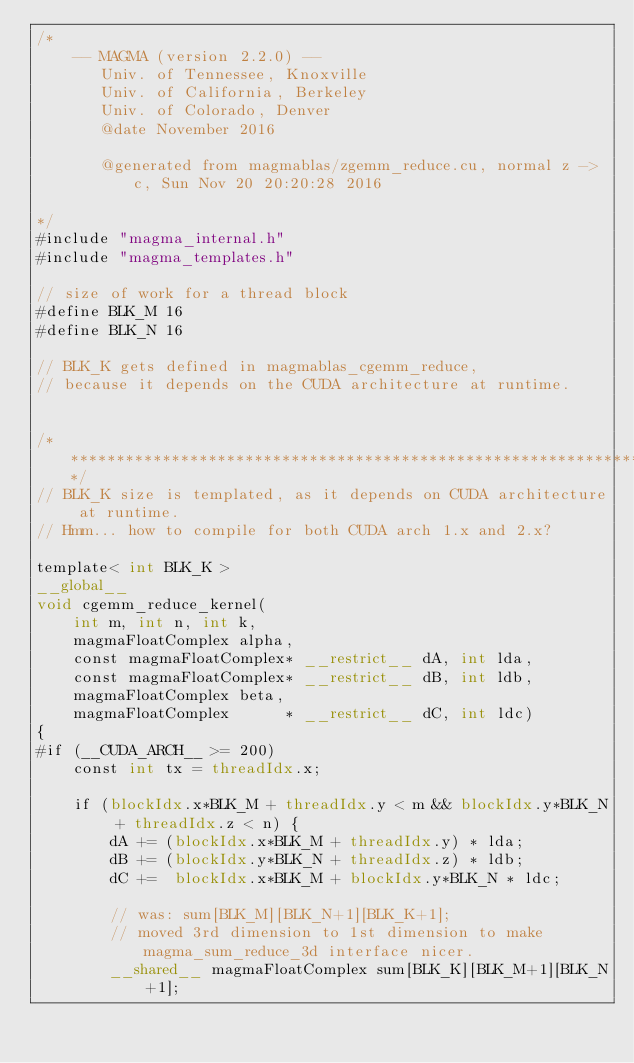<code> <loc_0><loc_0><loc_500><loc_500><_Cuda_>/*
    -- MAGMA (version 2.2.0) --
       Univ. of Tennessee, Knoxville
       Univ. of California, Berkeley
       Univ. of Colorado, Denver
       @date November 2016

       @generated from magmablas/zgemm_reduce.cu, normal z -> c, Sun Nov 20 20:20:28 2016

*/
#include "magma_internal.h"
#include "magma_templates.h"

// size of work for a thread block
#define BLK_M 16
#define BLK_N 16

// BLK_K gets defined in magmablas_cgemm_reduce,
// because it depends on the CUDA architecture at runtime.


/******************************************************************************/
// BLK_K size is templated, as it depends on CUDA architecture at runtime.
// Hmm... how to compile for both CUDA arch 1.x and 2.x?

template< int BLK_K >
__global__
void cgemm_reduce_kernel(
    int m, int n, int k,
    magmaFloatComplex alpha,
    const magmaFloatComplex* __restrict__ dA, int lda,
    const magmaFloatComplex* __restrict__ dB, int ldb,
    magmaFloatComplex beta,
    magmaFloatComplex      * __restrict__ dC, int ldc)
{
#if (__CUDA_ARCH__ >= 200)
    const int tx = threadIdx.x;
    
    if (blockIdx.x*BLK_M + threadIdx.y < m && blockIdx.y*BLK_N + threadIdx.z < n) {
        dA += (blockIdx.x*BLK_M + threadIdx.y) * lda;
        dB += (blockIdx.y*BLK_N + threadIdx.z) * ldb;
        dC +=  blockIdx.x*BLK_M + blockIdx.y*BLK_N * ldc;
        
        // was: sum[BLK_M][BLK_N+1][BLK_K+1];
        // moved 3rd dimension to 1st dimension to make magma_sum_reduce_3d interface nicer.
        __shared__ magmaFloatComplex sum[BLK_K][BLK_M+1][BLK_N+1];</code> 